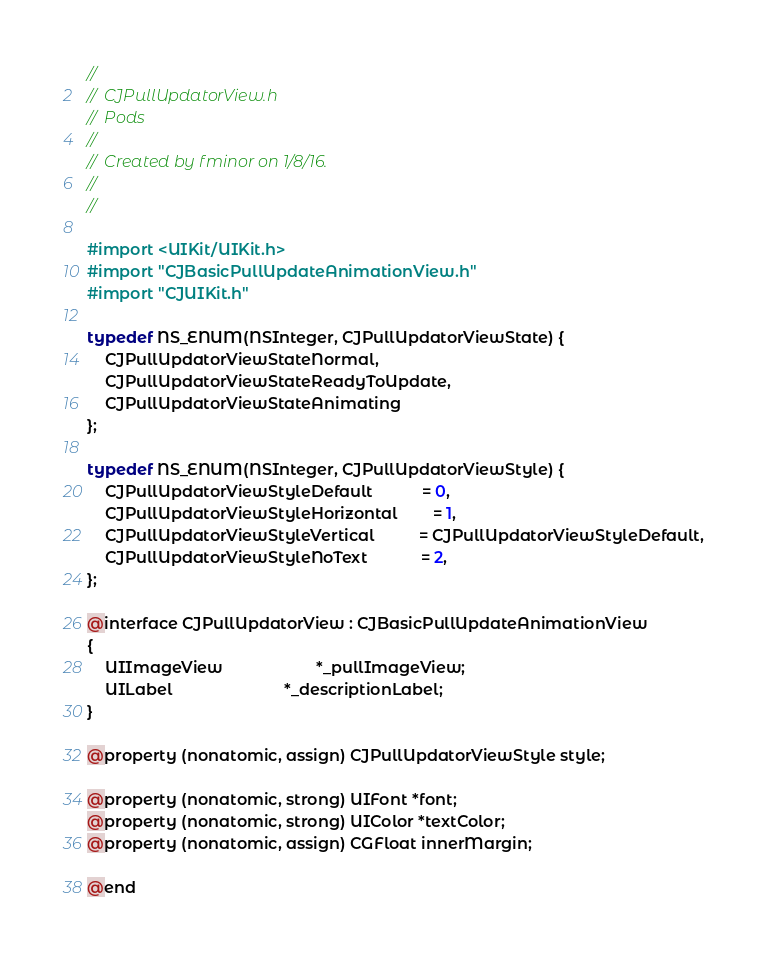<code> <loc_0><loc_0><loc_500><loc_500><_C_>//
//  CJPullUpdatorView.h
//  Pods
//
//  Created by fminor on 1/8/16.
//
//

#import <UIKit/UIKit.h>
#import "CJBasicPullUpdateAnimationView.h"
#import "CJUIKit.h"

typedef NS_ENUM(NSInteger, CJPullUpdatorViewState) {
    CJPullUpdatorViewStateNormal,
    CJPullUpdatorViewStateReadyToUpdate,
    CJPullUpdatorViewStateAnimating
};

typedef NS_ENUM(NSInteger, CJPullUpdatorViewStyle) {
    CJPullUpdatorViewStyleDefault           = 0,
    CJPullUpdatorViewStyleHorizontal        = 1,
    CJPullUpdatorViewStyleVertical          = CJPullUpdatorViewStyleDefault,
    CJPullUpdatorViewStyleNoText            = 2,
};

@interface CJPullUpdatorView : CJBasicPullUpdateAnimationView
{
    UIImageView                     *_pullImageView;
    UILabel                         *_descriptionLabel;
}

@property (nonatomic, assign) CJPullUpdatorViewStyle style;

@property (nonatomic, strong) UIFont *font;
@property (nonatomic, strong) UIColor *textColor;
@property (nonatomic, assign) CGFloat innerMargin;

@end
</code> 